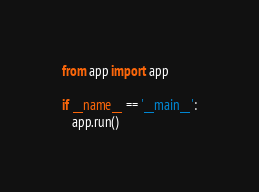<code> <loc_0><loc_0><loc_500><loc_500><_Python_>from app import app
 
if __name__ == '__main__':
   app.run()</code> 